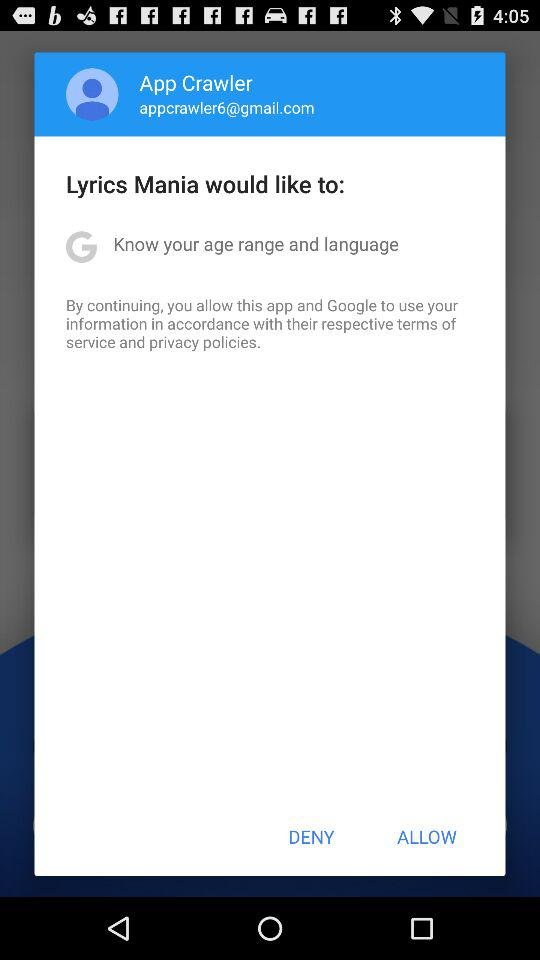What is the email address? The email address is appcrawler6@gmail.com. 